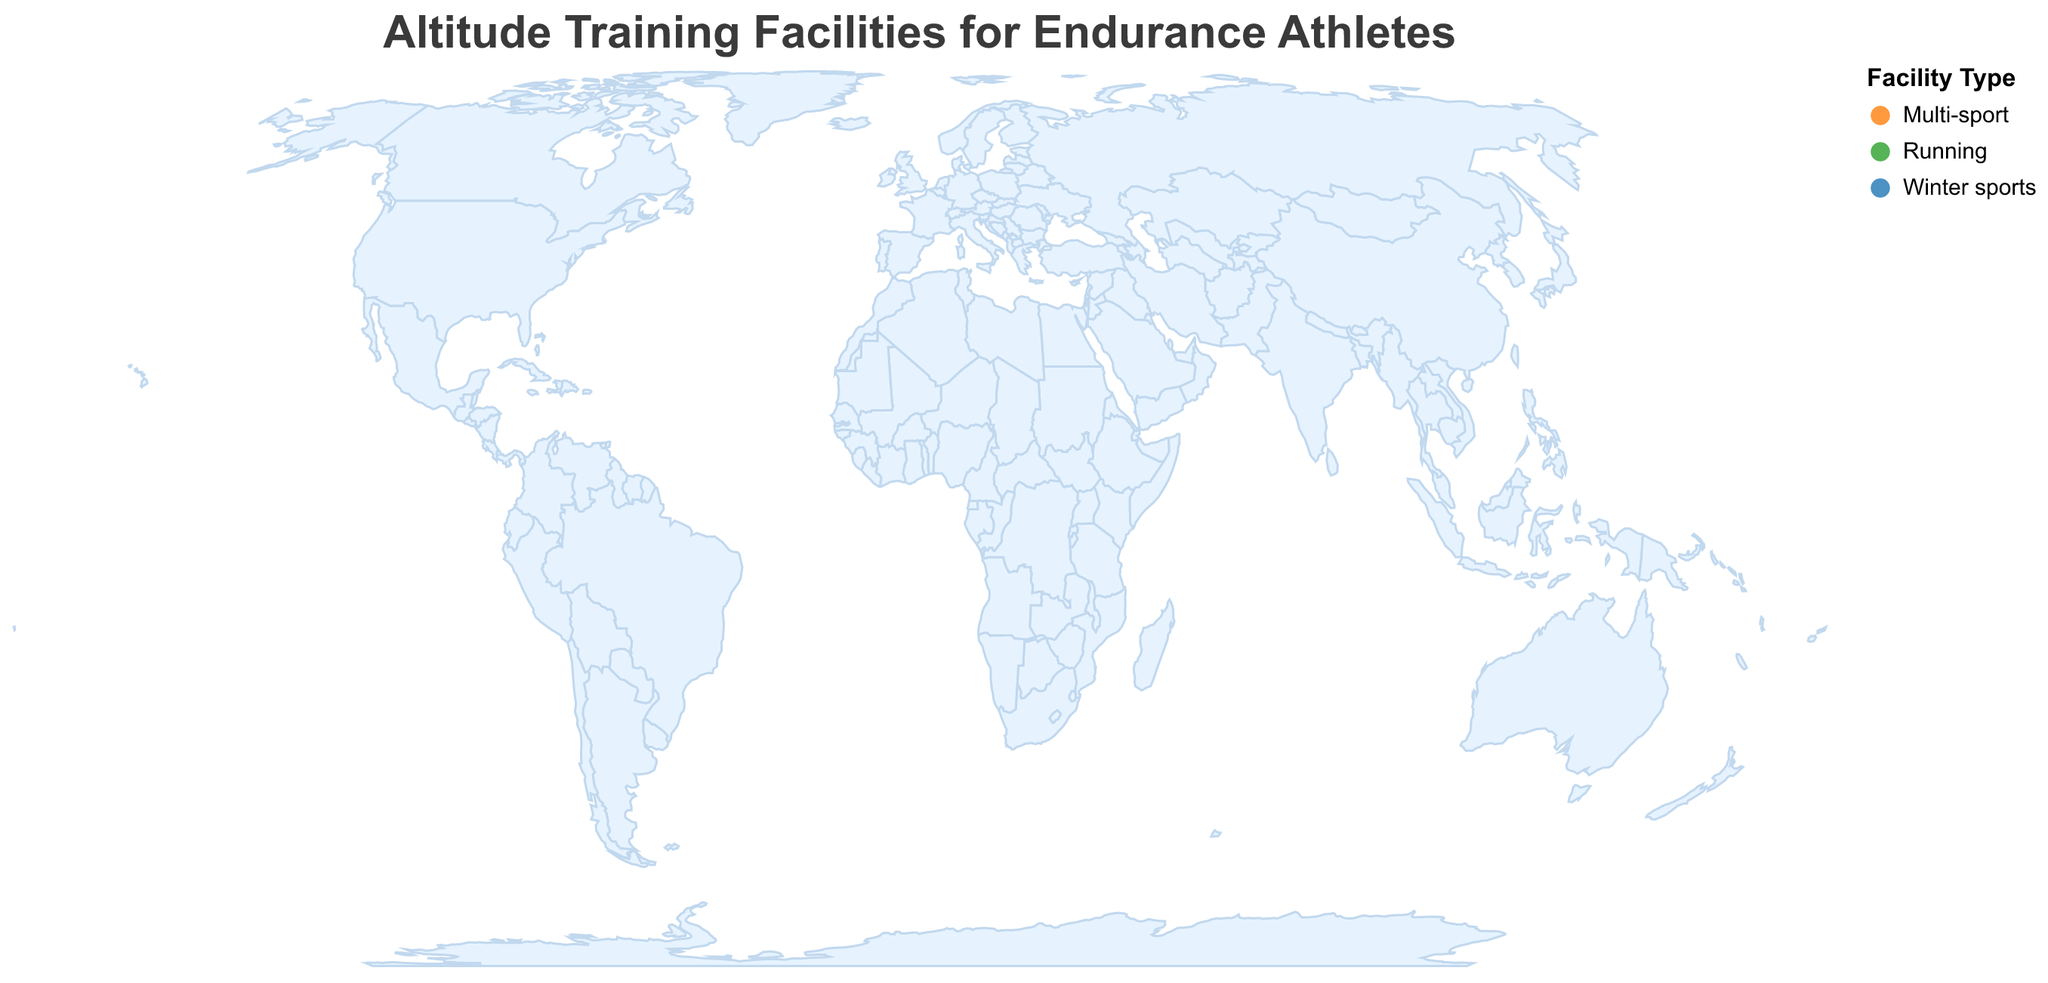What's the title of the figure? The title of the figure is displayed at the top center of the chart in a large font. It reads "Altitude Training Facilities for Endurance Athletes".
Answer: Altitude Training Facilities for Endurance Athletes How many training facilities are plotted on the map? By counting the number of circular markers with capacities on the map, we can see there are 10 training facilities plotted.
Answer: 10 Which facility has the highest altitude? By examining the tooltip details for each facility shown in the legend, we find that "Centro de Alto Rendimiento en Altura de Bogotá" has the highest altitude of 2640 meters.
Answer: Centro de Alto Rendimiento en Altura de Bogotá Which facility has the highest capacity, and what is its altitude? Checking the capacities listed in the tooltip for each facility, the "Colorado Springs Olympic Training Center" has the highest capacity of 300, and its altitude is 1839 meters.
Answer: Colorado Springs Olympic Training Center; 1839 meters Which type of facility is most common on the map? By observing the color-coded circles and counting the occurrences of each color in the legend, "Multi-sport" facilities, shown in orange, are the most frequent.
Answer: Multi-sport What is the average altitude of the facilities categorized as "Running"? The altitudes of the "Running" facilities are: 2400 (Iten), 2106 (Flagstaff), and 2414 (Mammoth Lakes). The average is calculated as (2400 + 2106 + 2414) / 3 = 2306.67 meters.
Answer: 2306.67 meters Which continent hosts the majority of these facilities? By examining the geographic locations (latitude and longitude) of the facilities, it is evident that most of them are in North America and Europe. North America has more facilities geographically closer when counting individually.
Answer: North America Which facilities are located in the Southern Hemisphere? By observing the latitude of each facility, only the "High Altitude Training Centre Iten" has a positive latitude close to the equator (0.6701), indicating its position in the Southern Hemisphere.
Answer: High Altitude Training Centre Iten Comparing the altitudes, which is higher: "Font Romeu Olympic Training Center" or "St. Moritz High Altitude Training Center"? Checking the altitudes in the tooltip, "Font Romeu Olympic Training Center" (1850 meters) and "St. Moritz High Altitude Training Center" (1856 meters), St. Moritz is higher by 6 meters.
Answer: St. Moritz High Altitude Training Center Among the facilities located in North America, which one has the lowest capacity? Looking at the tooltip data for facilities located in North America (Colorado Springs, Albuquerque, Flagstaff, Mammoth Lakes), "Mammoth Lakes High Altitude Training Facility" has the lowest capacity of 100.
Answer: Mammoth Lakes High Altitude Training Facility 